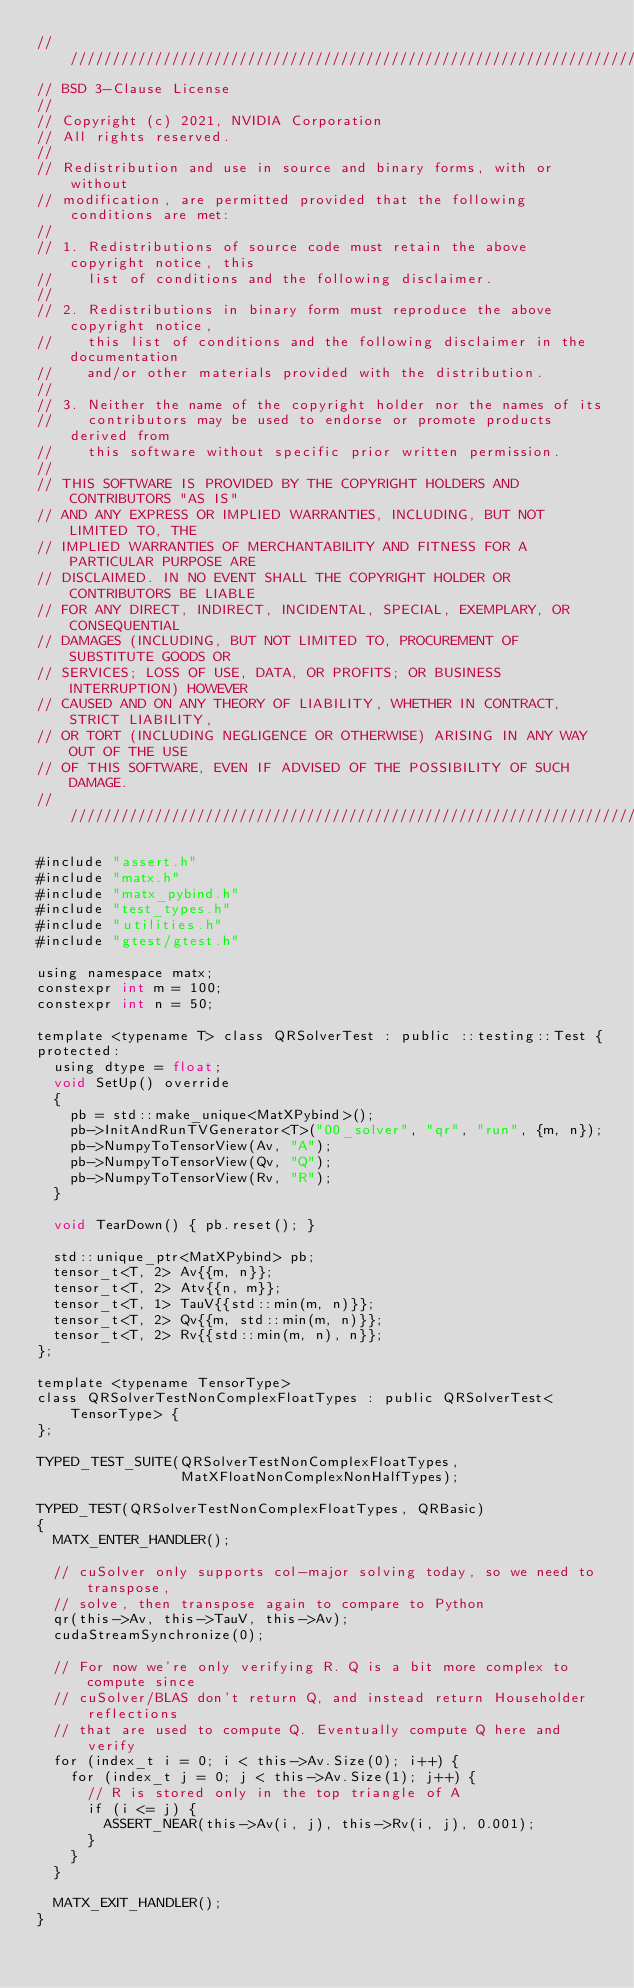<code> <loc_0><loc_0><loc_500><loc_500><_Cuda_>////////////////////////////////////////////////////////////////////////////////
// BSD 3-Clause License
//
// Copyright (c) 2021, NVIDIA Corporation
// All rights reserved.
//
// Redistribution and use in source and binary forms, with or without
// modification, are permitted provided that the following conditions are met:
//
// 1. Redistributions of source code must retain the above copyright notice, this
//    list of conditions and the following disclaimer.
//
// 2. Redistributions in binary form must reproduce the above copyright notice,
//    this list of conditions and the following disclaimer in the documentation
//    and/or other materials provided with the distribution.
//
// 3. Neither the name of the copyright holder nor the names of its
//    contributors may be used to endorse or promote products derived from
//    this software without specific prior written permission.
//
// THIS SOFTWARE IS PROVIDED BY THE COPYRIGHT HOLDERS AND CONTRIBUTORS "AS IS"
// AND ANY EXPRESS OR IMPLIED WARRANTIES, INCLUDING, BUT NOT LIMITED TO, THE
// IMPLIED WARRANTIES OF MERCHANTABILITY AND FITNESS FOR A PARTICULAR PURPOSE ARE
// DISCLAIMED. IN NO EVENT SHALL THE COPYRIGHT HOLDER OR CONTRIBUTORS BE LIABLE
// FOR ANY DIRECT, INDIRECT, INCIDENTAL, SPECIAL, EXEMPLARY, OR CONSEQUENTIAL
// DAMAGES (INCLUDING, BUT NOT LIMITED TO, PROCUREMENT OF SUBSTITUTE GOODS OR
// SERVICES; LOSS OF USE, DATA, OR PROFITS; OR BUSINESS INTERRUPTION) HOWEVER
// CAUSED AND ON ANY THEORY OF LIABILITY, WHETHER IN CONTRACT, STRICT LIABILITY,
// OR TORT (INCLUDING NEGLIGENCE OR OTHERWISE) ARISING IN ANY WAY OUT OF THE USE
// OF THIS SOFTWARE, EVEN IF ADVISED OF THE POSSIBILITY OF SUCH DAMAGE.
/////////////////////////////////////////////////////////////////////////////////

#include "assert.h"
#include "matx.h"
#include "matx_pybind.h"
#include "test_types.h"
#include "utilities.h"
#include "gtest/gtest.h"

using namespace matx;
constexpr int m = 100;
constexpr int n = 50;

template <typename T> class QRSolverTest : public ::testing::Test {
protected:
  using dtype = float;
  void SetUp() override
  {
    pb = std::make_unique<MatXPybind>();
    pb->InitAndRunTVGenerator<T>("00_solver", "qr", "run", {m, n});
    pb->NumpyToTensorView(Av, "A");
    pb->NumpyToTensorView(Qv, "Q");
    pb->NumpyToTensorView(Rv, "R");
  }

  void TearDown() { pb.reset(); }

  std::unique_ptr<MatXPybind> pb;
  tensor_t<T, 2> Av{{m, n}};
  tensor_t<T, 2> Atv{{n, m}};
  tensor_t<T, 1> TauV{{std::min(m, n)}};
  tensor_t<T, 2> Qv{{m, std::min(m, n)}};
  tensor_t<T, 2> Rv{{std::min(m, n), n}};
};

template <typename TensorType>
class QRSolverTestNonComplexFloatTypes : public QRSolverTest<TensorType> {
};

TYPED_TEST_SUITE(QRSolverTestNonComplexFloatTypes,
                 MatXFloatNonComplexNonHalfTypes);

TYPED_TEST(QRSolverTestNonComplexFloatTypes, QRBasic)
{
  MATX_ENTER_HANDLER();

  // cuSolver only supports col-major solving today, so we need to transpose,
  // solve, then transpose again to compare to Python
  qr(this->Av, this->TauV, this->Av);
  cudaStreamSynchronize(0);

  // For now we're only verifying R. Q is a bit more complex to compute since
  // cuSolver/BLAS don't return Q, and instead return Householder reflections
  // that are used to compute Q. Eventually compute Q here and verify
  for (index_t i = 0; i < this->Av.Size(0); i++) {
    for (index_t j = 0; j < this->Av.Size(1); j++) {
      // R is stored only in the top triangle of A
      if (i <= j) {
        ASSERT_NEAR(this->Av(i, j), this->Rv(i, j), 0.001);
      }
    }
  }

  MATX_EXIT_HANDLER();
}
</code> 